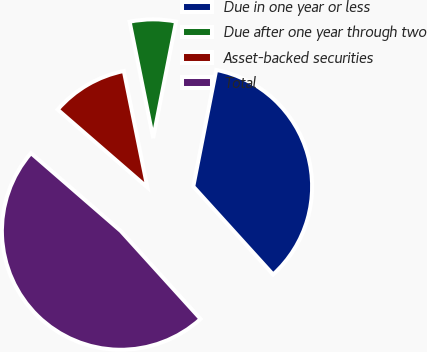Convert chart. <chart><loc_0><loc_0><loc_500><loc_500><pie_chart><fcel>Due in one year or less<fcel>Due after one year through two<fcel>Asset-backed securities<fcel>Total<nl><fcel>35.18%<fcel>6.27%<fcel>10.45%<fcel>48.09%<nl></chart> 